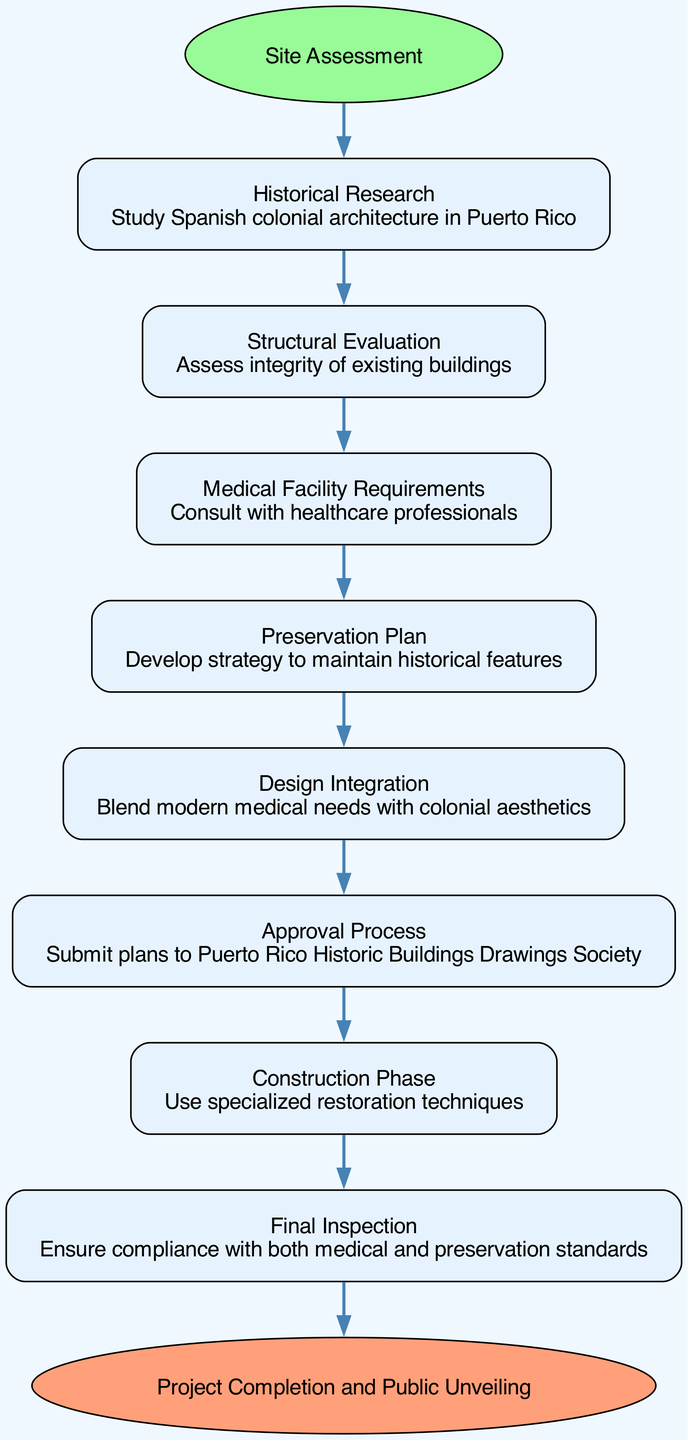What is the first step in the pathway? The pathway starts with the "Site Assessment" as indicated by the starting node in the diagram. Therefore, the first step is directly connected from the start node.
Answer: Site Assessment How many steps are there in the pathway? By counting all the steps listed in the diagram between the start and end, we have a total of 8 distinct steps.
Answer: 8 What follows the "Structural Evaluation"? The "Medical Facility Requirements" step immediately follows the "Structural Evaluation" step based on the sequential flow of the diagram.
Answer: Medical Facility Requirements Which entity must approve the preservation plan? The "Approval Process" mentions submitting plans to the "Puerto Rico Historic Buildings Drawings Society," indicating that this entity is responsible for approval.
Answer: Puerto Rico Historic Buildings Drawings Society What is the last step before project completion? The "Final Inspection" is the last step that comes just before reaching the end of the pathway, ensuring compliance with various standards.
Answer: Final Inspection How does "Design Integration" relate to "Preservation Plan"? "Design Integration" follows "Preservation Plan" in the pathway, indicating that the design must consider the prior preservation strategy that was developed.
Answer: It follows What is the purpose of the "Construction Phase"? The "Construction Phase" focuses on using specialized restoration techniques, indicating its role is to implement the preservation strategies effectively.
Answer: Specialized restoration techniques How many nodes are specifically related to medical facility needs? Upon inspection, there are two nodes directly tied to medical facility needs: "Medical Facility Requirements" and "Design Integration," highlighting their connection to healthcare.
Answer: 2 What is the main intent of the "Historical Research" step? The "Historical Research" step aims to study Spanish colonial architecture in Puerto Rico, which is essential for understanding the historical context of preservation efforts.
Answer: Study Spanish colonial architecture in Puerto Rico 